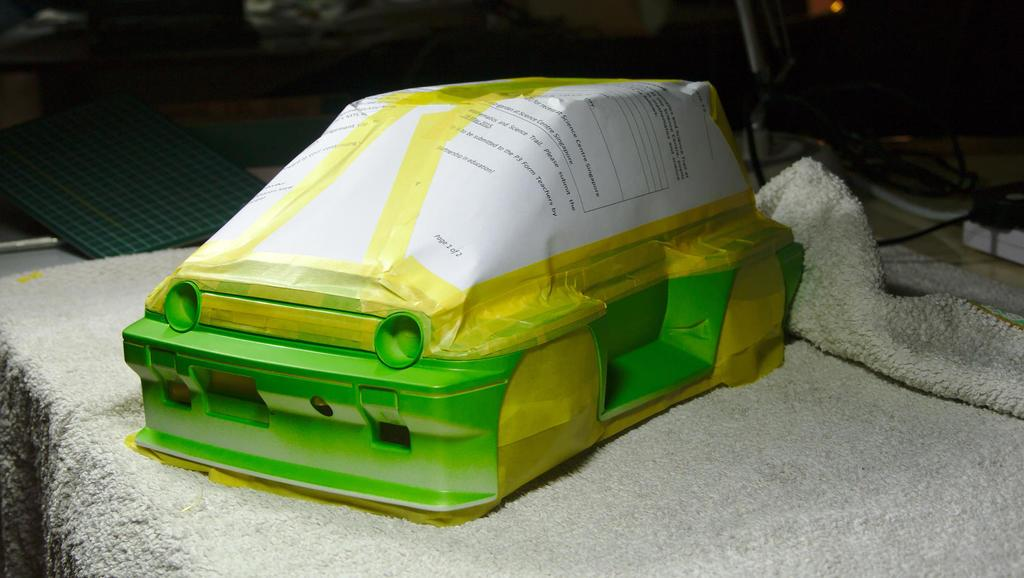What color is the object in the image? The object in the image is green. What is the object placed on? The object is on a mat. How many sisters are present in the image? There are no sisters mentioned or visible in the image. 